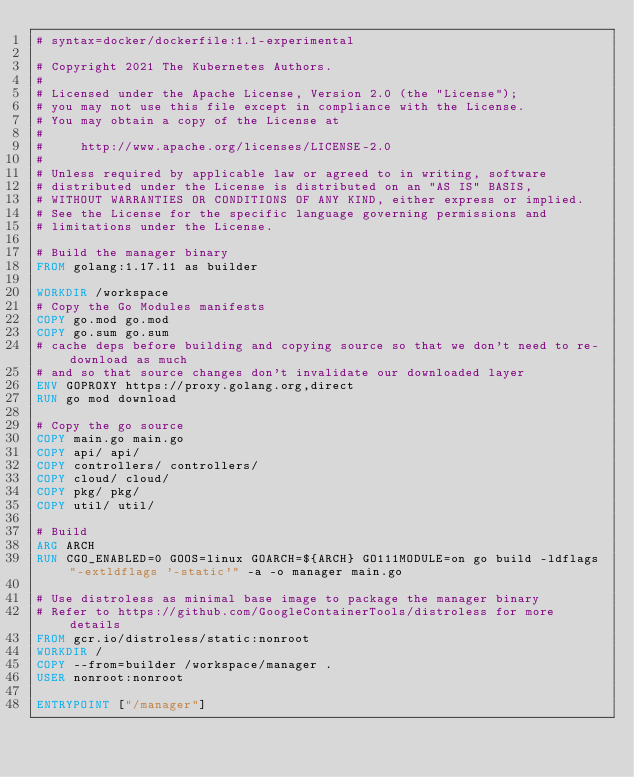Convert code to text. <code><loc_0><loc_0><loc_500><loc_500><_Dockerfile_># syntax=docker/dockerfile:1.1-experimental

# Copyright 2021 The Kubernetes Authors.
#
# Licensed under the Apache License, Version 2.0 (the "License");
# you may not use this file except in compliance with the License.
# You may obtain a copy of the License at
#
#     http://www.apache.org/licenses/LICENSE-2.0
#
# Unless required by applicable law or agreed to in writing, software
# distributed under the License is distributed on an "AS IS" BASIS,
# WITHOUT WARRANTIES OR CONDITIONS OF ANY KIND, either express or implied.
# See the License for the specific language governing permissions and
# limitations under the License.

# Build the manager binary
FROM golang:1.17.11 as builder

WORKDIR /workspace
# Copy the Go Modules manifests
COPY go.mod go.mod
COPY go.sum go.sum
# cache deps before building and copying source so that we don't need to re-download as much
# and so that source changes don't invalidate our downloaded layer
ENV GOPROXY https://proxy.golang.org,direct
RUN go mod download

# Copy the go source
COPY main.go main.go
COPY api/ api/
COPY controllers/ controllers/
COPY cloud/ cloud/
COPY pkg/ pkg/
COPY util/ util/

# Build
ARG ARCH
RUN CGO_ENABLED=0 GOOS=linux GOARCH=${ARCH} GO111MODULE=on go build -ldflags "-extldflags '-static'" -a -o manager main.go

# Use distroless as minimal base image to package the manager binary
# Refer to https://github.com/GoogleContainerTools/distroless for more details
FROM gcr.io/distroless/static:nonroot
WORKDIR /
COPY --from=builder /workspace/manager .
USER nonroot:nonroot

ENTRYPOINT ["/manager"]
</code> 